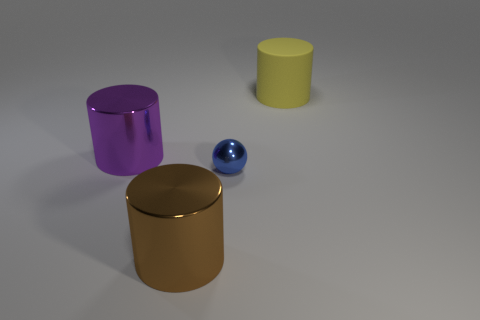Is there anything else that is the same size as the blue metallic ball?
Provide a short and direct response. No. There is a brown cylinder; are there any big yellow things left of it?
Make the answer very short. No. What size is the metal cylinder on the right side of the thing to the left of the big shiny thing that is in front of the small blue shiny sphere?
Your answer should be very brief. Large. Do the big shiny object behind the large brown metal cylinder and the big shiny object that is in front of the large purple metal thing have the same shape?
Offer a very short reply. Yes. There is another metallic thing that is the same shape as the big brown metallic thing; what size is it?
Offer a terse response. Large. How many brown objects are the same material as the purple cylinder?
Your response must be concise. 1. What is the small thing made of?
Provide a short and direct response. Metal. What is the shape of the metallic object that is on the right side of the large metal thing that is in front of the purple shiny cylinder?
Provide a succinct answer. Sphere. What is the shape of the metal thing to the left of the large brown cylinder?
Offer a very short reply. Cylinder. How many other tiny shiny balls have the same color as the tiny shiny ball?
Make the answer very short. 0. 